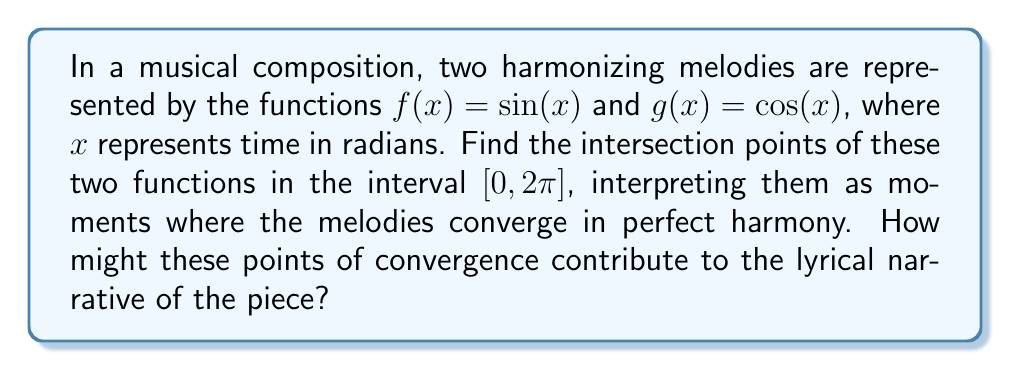Can you answer this question? To find the intersection points of $f(x) = \sin(x)$ and $g(x) = \cos(x)$, we need to solve the equation:

$$\sin(x) = \cos(x)$$

This is equivalent to:

$$\sin(x) - \cos(x) = 0$$

To solve this, we can use the trigonometric identity:

$$\sin(x) - \cos(x) = \sqrt{2} \sin(x - \frac{\pi}{4})$$

So our equation becomes:

$$\sqrt{2} \sin(x - \frac{\pi}{4}) = 0$$

The sine function equals zero when its argument is a multiple of $\pi$. Therefore:

$$x - \frac{\pi}{4} = n\pi$$
$$x = n\pi + \frac{\pi}{4}$$

Where $n$ is an integer.

In the interval $[0, 2\pi]$, there are two solutions:

1. When $n = 0$: $x = \frac{\pi}{4}$
2. When $n = 1$: $x = \frac{5\pi}{4}$

These points represent moments in the composition where the two melodies intersect, symbolizing a perfect harmony or convergence in the musical narrative.

[asy]
import graph;
size(200,200);
real f(real x) {return sin(x);}
real g(real x) {return cos(x);}
draw(graph(f,0,2*pi),blue);
draw(graph(g,0,2*pi),red);
draw((0,0)--(2*pi,0),arrow=Arrow(TeXHead));
draw((0,-1)--(0,1),arrow=Arrow(TeXHead));
label("$f(x)=\sin(x)$",(pi,0.5),blue);
label("$g(x)=\cos(x)$",(pi,-0.5),red);
dot((pi/4,sqrt(2)/2));
dot((5*pi/4,-sqrt(2)/2));
label("$(\frac{\pi}{4},\frac{\sqrt{2}}{2})$",(pi/4,sqrt(2)/2),NE);
label("$(\frac{5\pi}{4},-\frac{\sqrt{2}}{2})$",(5*pi/4,-sqrt(2)/2),SW);
[/asy]

From a literary perspective, these intersection points could be interpreted as pivotal moments in the song's narrative. The first intersection at $\frac{\pi}{4}$ might represent an initial moment of clarity or realization, while the second at $\frac{5\pi}{4}$ could symbolize a resolution or final epiphany in the lyrical story.
Answer: The intersection points of $f(x) = \sin(x)$ and $g(x) = \cos(x)$ in the interval $[0, 2\pi]$ are $(\frac{\pi}{4}, \frac{\sqrt{2}}{2})$ and $(\frac{5\pi}{4}, -\frac{\sqrt{2}}{2})$. 